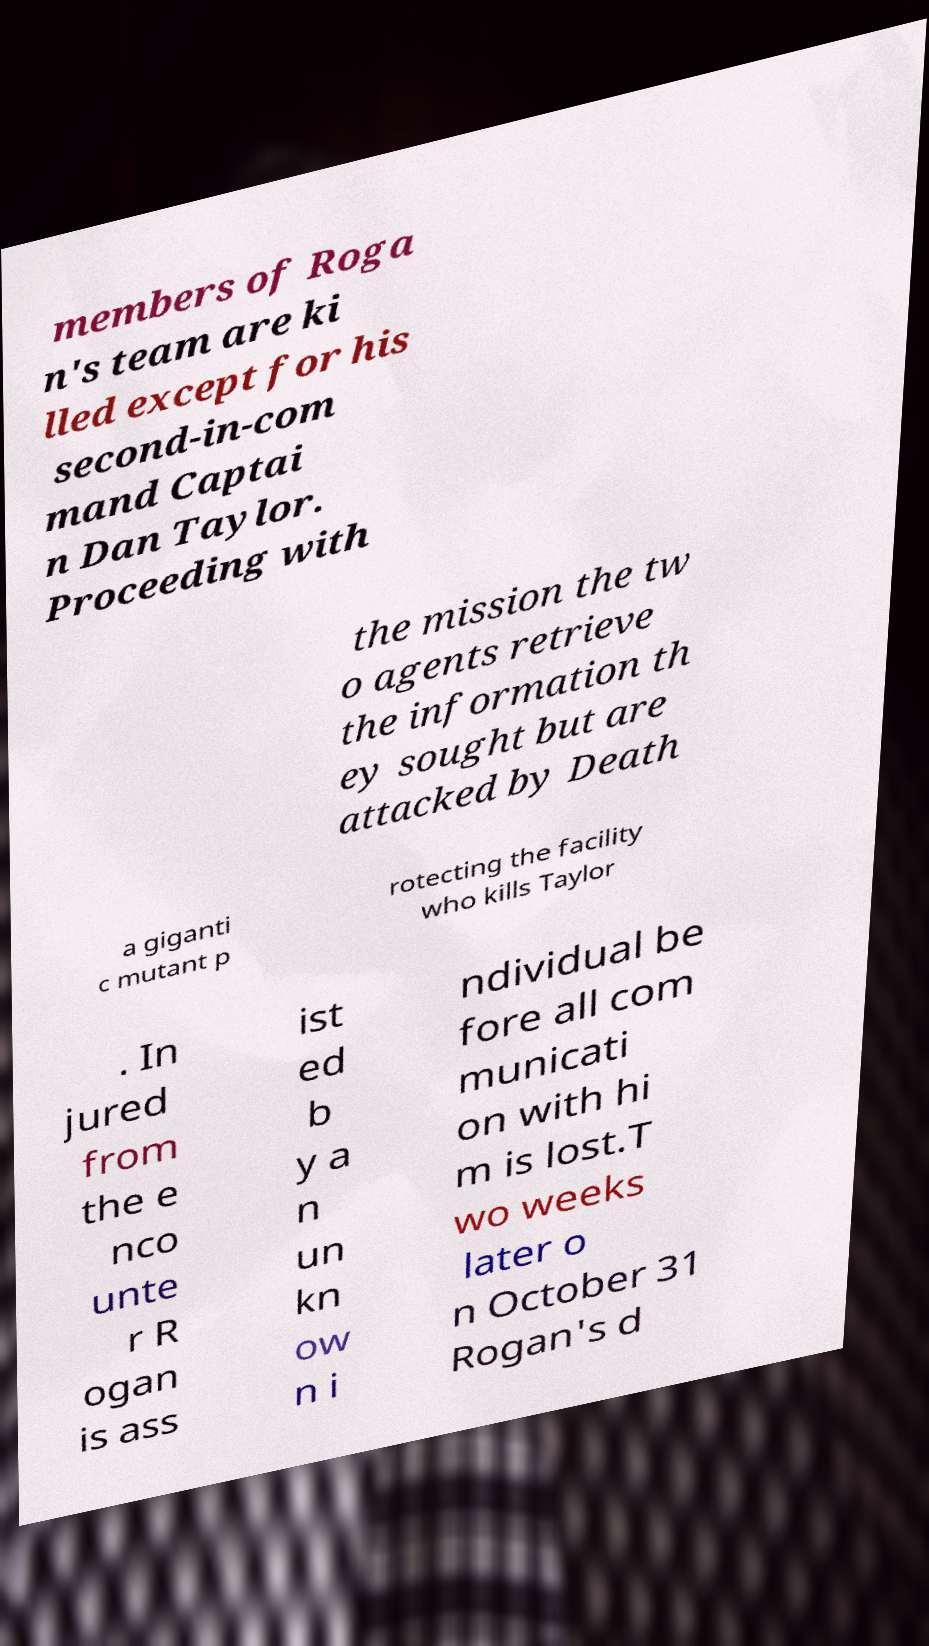For documentation purposes, I need the text within this image transcribed. Could you provide that? members of Roga n's team are ki lled except for his second-in-com mand Captai n Dan Taylor. Proceeding with the mission the tw o agents retrieve the information th ey sought but are attacked by Death a giganti c mutant p rotecting the facility who kills Taylor . In jured from the e nco unte r R ogan is ass ist ed b y a n un kn ow n i ndividual be fore all com municati on with hi m is lost.T wo weeks later o n October 31 Rogan's d 